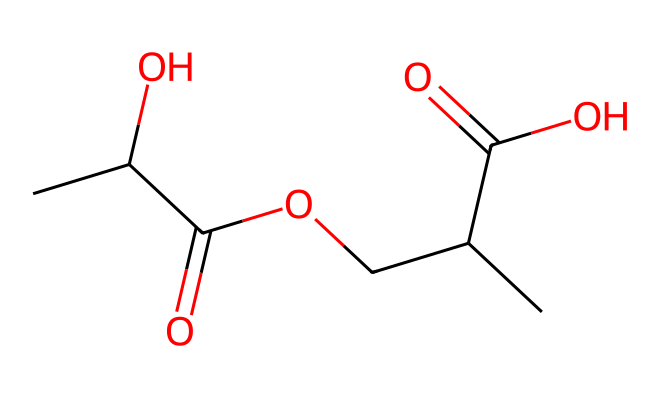What type of functional groups are present in this chemical? Analyzing the structure reveals carboxylic acid groups (–COOH) and ether groups (–O–) characterizing this ester compound.
Answer: carboxylic acid and ether How many carbon atoms are in the chemical structure? By counting the carbon atoms in the SMILES representation, we find 8 carbon atoms total within the structure.
Answer: 8 What is the molecular weight of the chemical represented by this SMILES? Calculating the molecular weight involves summing the weights of all the atoms present: carbon, hydrogen, and oxygen. This gives us a total molecular weight of approximately 174.20 g/mol.
Answer: 174.20 What type of ester is represented in the chemical structure? The ester described in the SMILES has fatty acid and alcohol components, confirming it is a diester, as it contains two ester groups.
Answer: diester What does the presence of the carboxylic acid functional group indicate about the properties of this ester? The presence of carboxylic acid groups suggests the potential for hydrogen bonding, which can affect solubility and melting points, leading to possible biodegradability.
Answer: potential for hydrogen bonding How many ester linkages can be identified in the structure? Upon examination of the SMILES format, there are two distinct ester linkages (–COO–), as depicted by the connection of the carboxylic acid groups with the alcohol components.
Answer: 2 